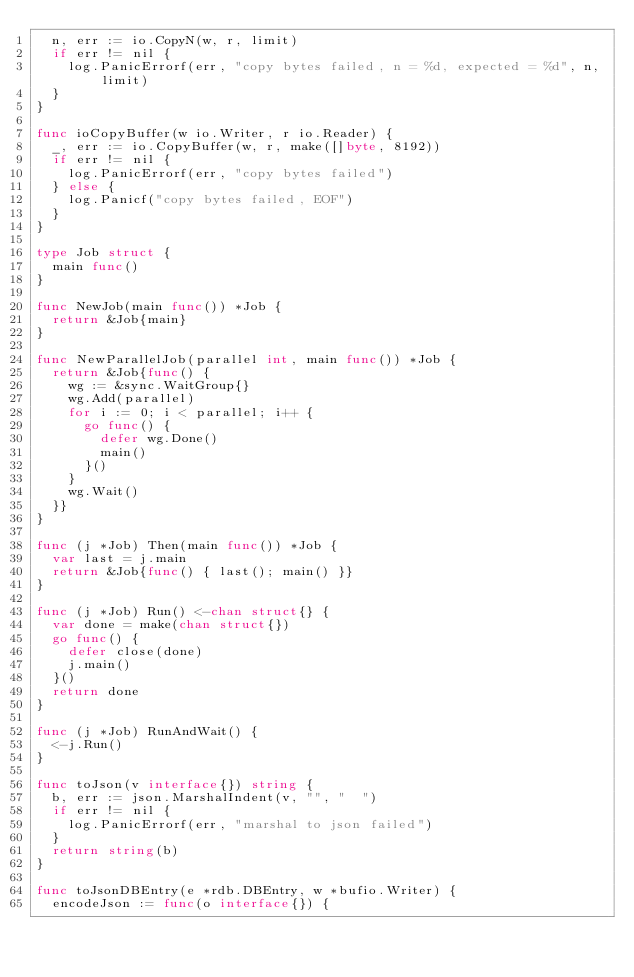<code> <loc_0><loc_0><loc_500><loc_500><_Go_>	n, err := io.CopyN(w, r, limit)
	if err != nil {
		log.PanicErrorf(err, "copy bytes failed, n = %d, expected = %d", n, limit)
	}
}

func ioCopyBuffer(w io.Writer, r io.Reader) {
	_, err := io.CopyBuffer(w, r, make([]byte, 8192))
	if err != nil {
		log.PanicErrorf(err, "copy bytes failed")
	} else {
		log.Panicf("copy bytes failed, EOF")
	}
}

type Job struct {
	main func()
}

func NewJob(main func()) *Job {
	return &Job{main}
}

func NewParallelJob(parallel int, main func()) *Job {
	return &Job{func() {
		wg := &sync.WaitGroup{}
		wg.Add(parallel)
		for i := 0; i < parallel; i++ {
			go func() {
				defer wg.Done()
				main()
			}()
		}
		wg.Wait()
	}}
}

func (j *Job) Then(main func()) *Job {
	var last = j.main
	return &Job{func() { last(); main() }}
}

func (j *Job) Run() <-chan struct{} {
	var done = make(chan struct{})
	go func() {
		defer close(done)
		j.main()
	}()
	return done
}

func (j *Job) RunAndWait() {
	<-j.Run()
}

func toJson(v interface{}) string {
	b, err := json.MarshalIndent(v, "", "  ")
	if err != nil {
		log.PanicErrorf(err, "marshal to json failed")
	}
	return string(b)
}

func toJsonDBEntry(e *rdb.DBEntry, w *bufio.Writer) {
	encodeJson := func(o interface{}) {</code> 